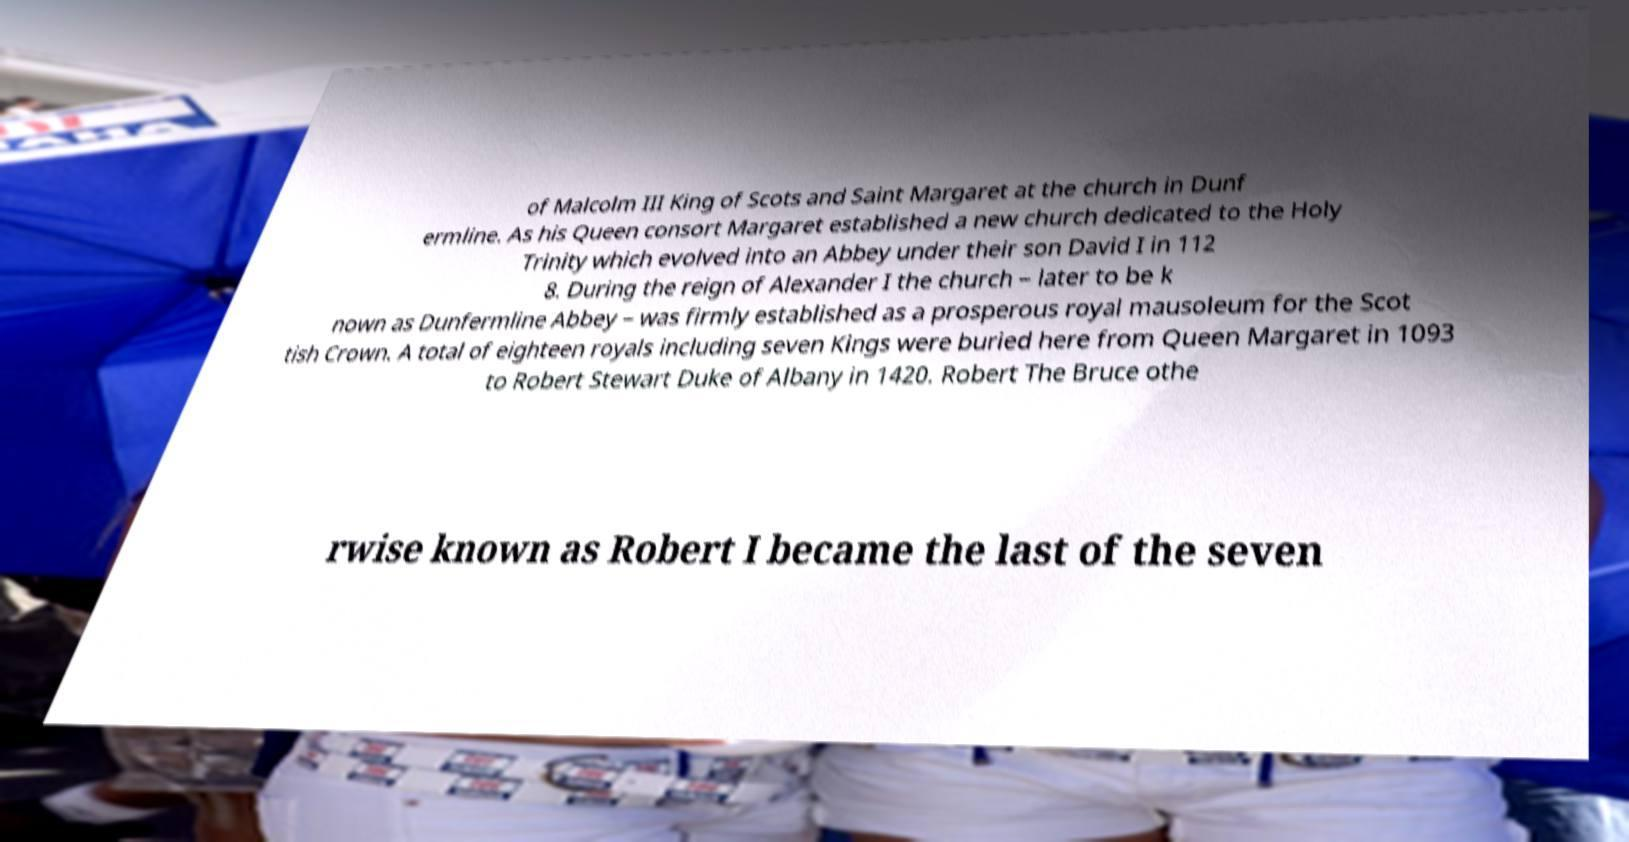For documentation purposes, I need the text within this image transcribed. Could you provide that? of Malcolm III King of Scots and Saint Margaret at the church in Dunf ermline. As his Queen consort Margaret established a new church dedicated to the Holy Trinity which evolved into an Abbey under their son David I in 112 8. During the reign of Alexander I the church – later to be k nown as Dunfermline Abbey – was firmly established as a prosperous royal mausoleum for the Scot tish Crown. A total of eighteen royals including seven Kings were buried here from Queen Margaret in 1093 to Robert Stewart Duke of Albany in 1420. Robert The Bruce othe rwise known as Robert I became the last of the seven 